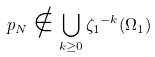Convert formula to latex. <formula><loc_0><loc_0><loc_500><loc_500>p _ { N } \notin \bigcup _ { k \geq 0 } { \zeta _ { 1 } } ^ { - k } ( \Omega _ { 1 } )</formula> 